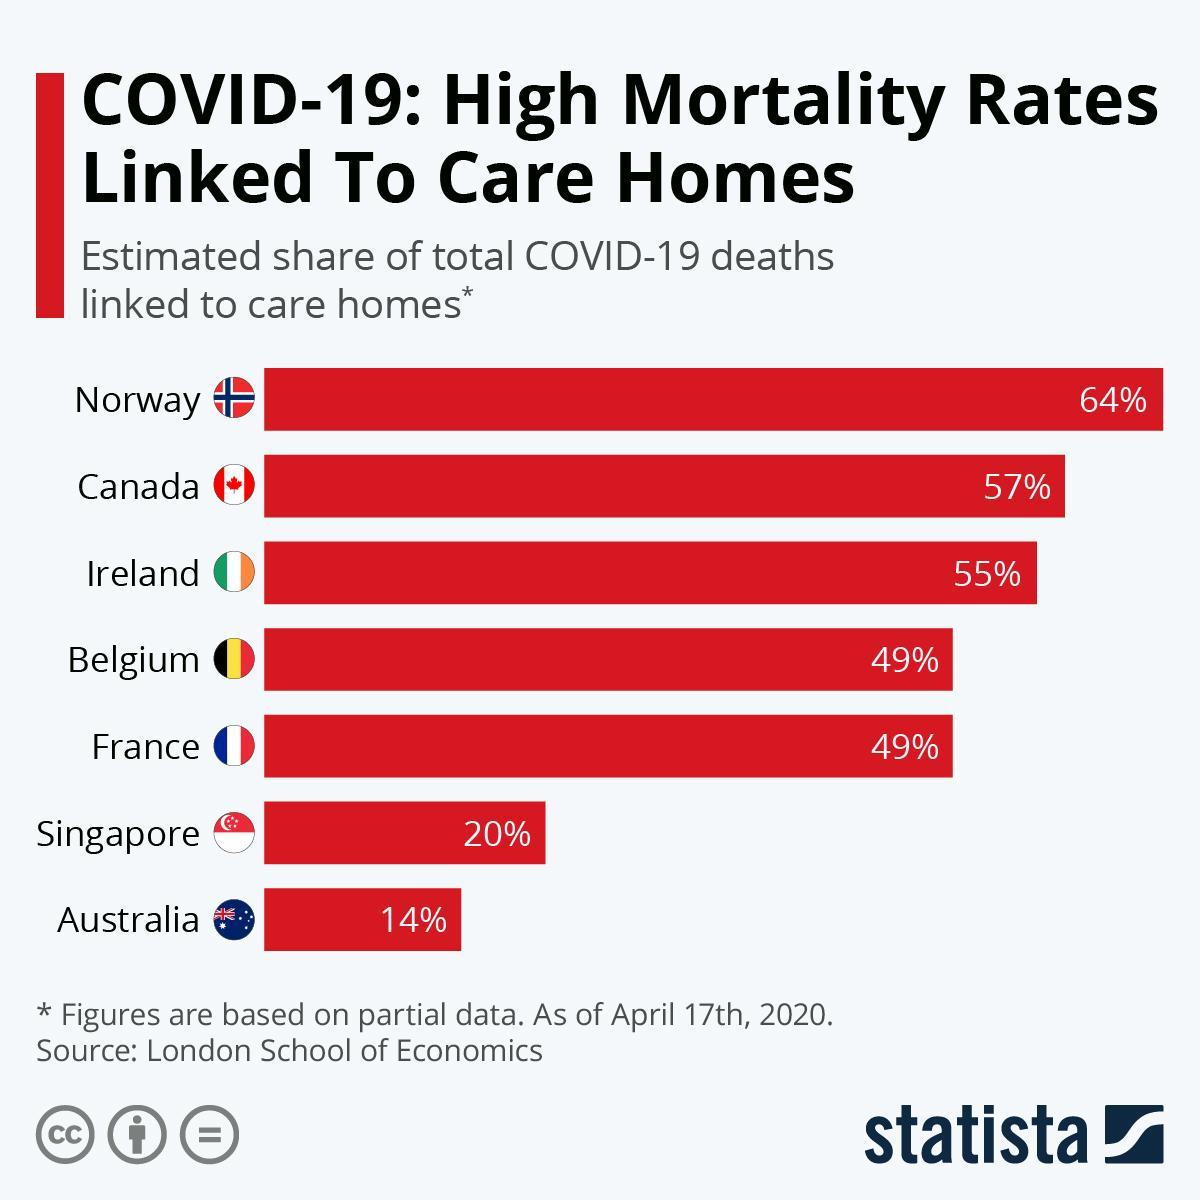Which country has the highest share of  total Covid-19 deaths linked to care homes as of April 17th, 2020?
Answer the question with a short phrase. Norway Which country has the least share of total Covid-19 deaths linked to care homes as of April 17th, 2020? Australia Which country has the second highest share of total Covid-19 deaths linked to care homes as of April 17th, 2020? Canada What is the estimated share of total Covid-19 deaths linked to care homes in Canada as of April 17th, 2020? 57% What is the estimated share of total Covid-19 deaths linked to care homes in Singapore as of April 17th, 2020? 20% 